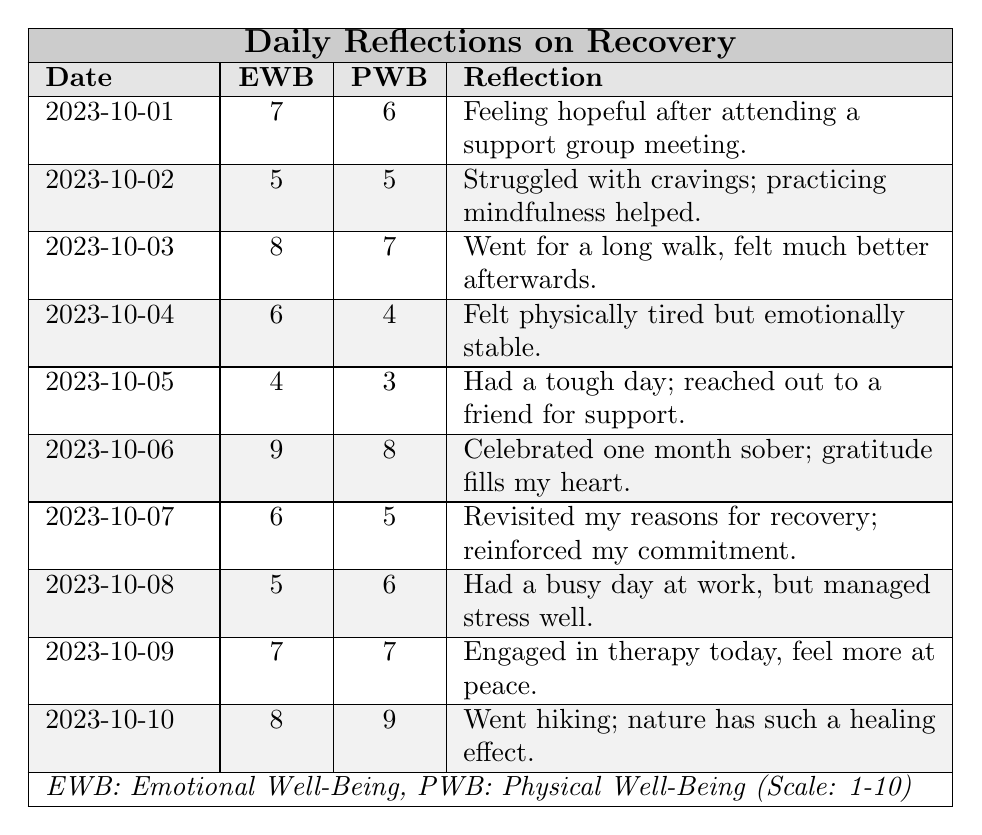What was the emotional well-being rating on 2023-10-06? The emotional well-being (EWB) rating on that date is directly seen in the table, which lists it as 9.
Answer: 9 How did the physical well-being rating change from 2023-10-02 to 2023-10-06? The physical well-being (PWB) on 2023-10-02 was 5, and on 2023-10-06 it was 8. The change can be calculated as 8 - 5 = 3.
Answer: Increased by 3 What was the total score for emotional well-being for all days recorded? Adding the EWB ratings from the table gives us (7 + 5 + 8 + 6 + 4 + 9 + 6 + 5 + 7 + 8) = 65.
Answer: 65 On which date did the individual feel the most emotionally stable? The highest emotional well-being rating is 9 on 2023-10-06, indicating the individual felt emotionally the best.
Answer: 2023-10-06 Was there a day when both emotional and physical well-being ratings were below 5? Yes, on 2023-10-05, the emotional well-being was 4 and the physical well-being was 3, both below 5.
Answer: Yes What is the average emotional well-being rating for the first week of October? The ratings from October 1st to October 7th are: 7, 5, 8, 6, 4, 9, and 6. Sum them to get 45 and divide by 7, resulting in approximately 6.43.
Answer: Approximately 6.43 How did the emotional well-being on 2023-10-09 compare to the previous day, 2023-10-08? The emotional well-being was 7 on 2023-10-09 and 5 on 2023-10-08; 7 is greater than 5, indicating improvement.
Answer: Improved Was the physical well-being consistently higher than the emotional well-being throughout the week? No, on 2023-10-05, the physical well-being was 3 while emotional was 4, showing inconsistency.
Answer: No What day showed the highest combined score of emotional and physical well-being? The combined score of emotional and physical well-being is highest on 2023-10-06, with EWB of 9 and PWB of 8, totaling 17.
Answer: 2023-10-06 What reflections correlated with lower emotional well-being ratings? A key reflection for lower emotional well-being (4 on 2023-10-05) was having a tough day and reaching out for support.
Answer: Having a tough day 